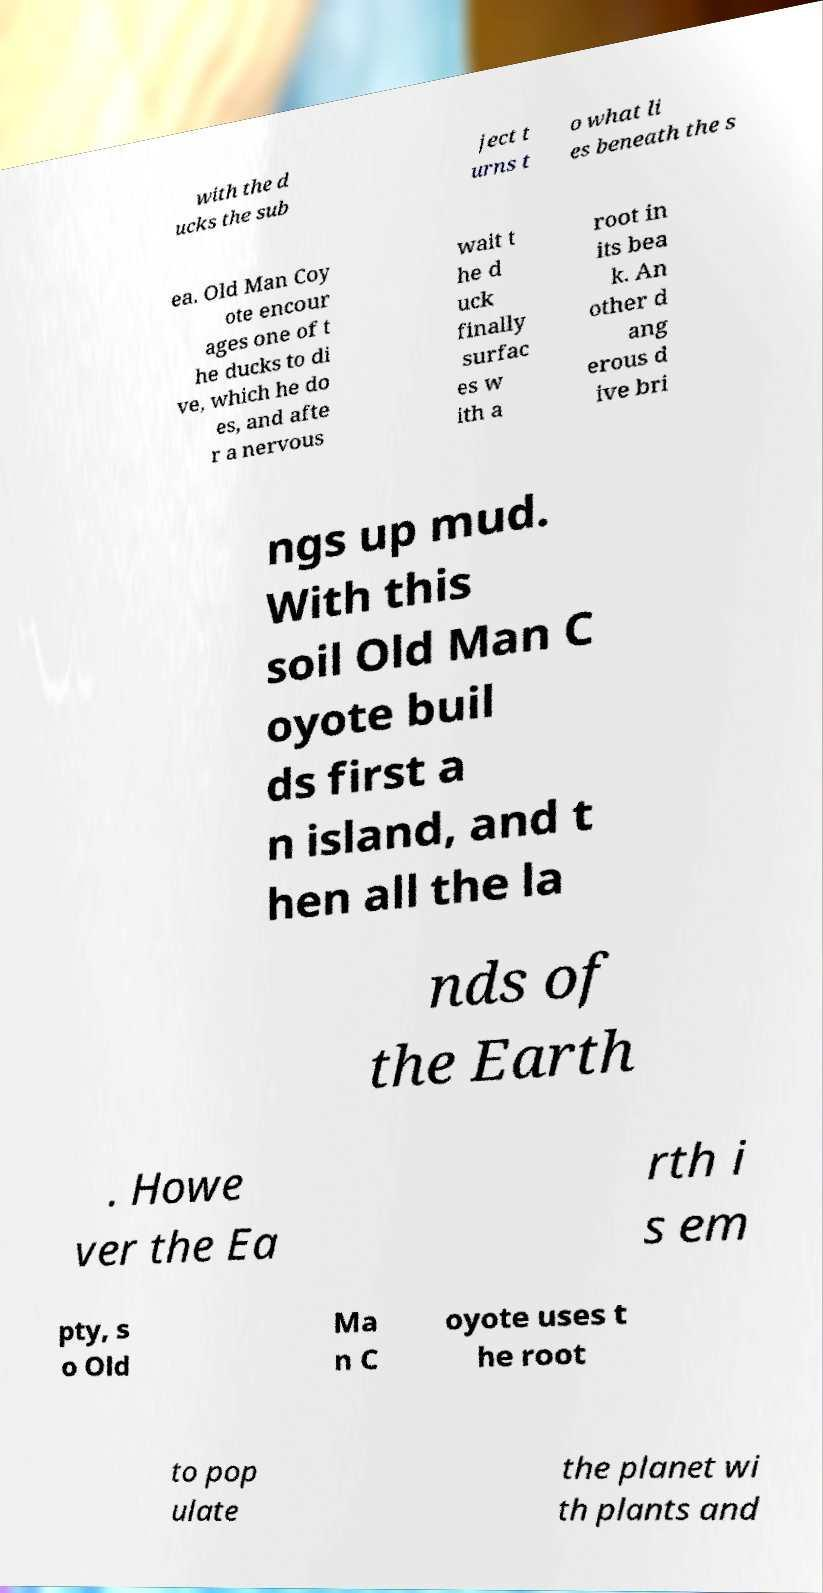Please identify and transcribe the text found in this image. with the d ucks the sub ject t urns t o what li es beneath the s ea. Old Man Coy ote encour ages one of t he ducks to di ve, which he do es, and afte r a nervous wait t he d uck finally surfac es w ith a root in its bea k. An other d ang erous d ive bri ngs up mud. With this soil Old Man C oyote buil ds first a n island, and t hen all the la nds of the Earth . Howe ver the Ea rth i s em pty, s o Old Ma n C oyote uses t he root to pop ulate the planet wi th plants and 